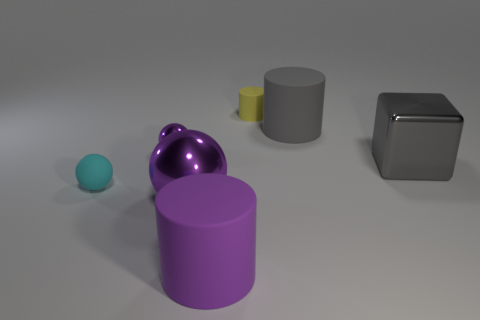Add 1 small blue shiny objects. How many objects exist? 8 Subtract all big spheres. How many spheres are left? 2 Subtract all purple balls. How many balls are left? 1 Add 1 metal cubes. How many metal cubes exist? 2 Subtract 0 green cylinders. How many objects are left? 7 Subtract all cylinders. How many objects are left? 4 Subtract 1 cylinders. How many cylinders are left? 2 Subtract all yellow cubes. Subtract all red cylinders. How many cubes are left? 1 Subtract all yellow spheres. How many green cylinders are left? 0 Subtract all red cubes. Subtract all metallic spheres. How many objects are left? 5 